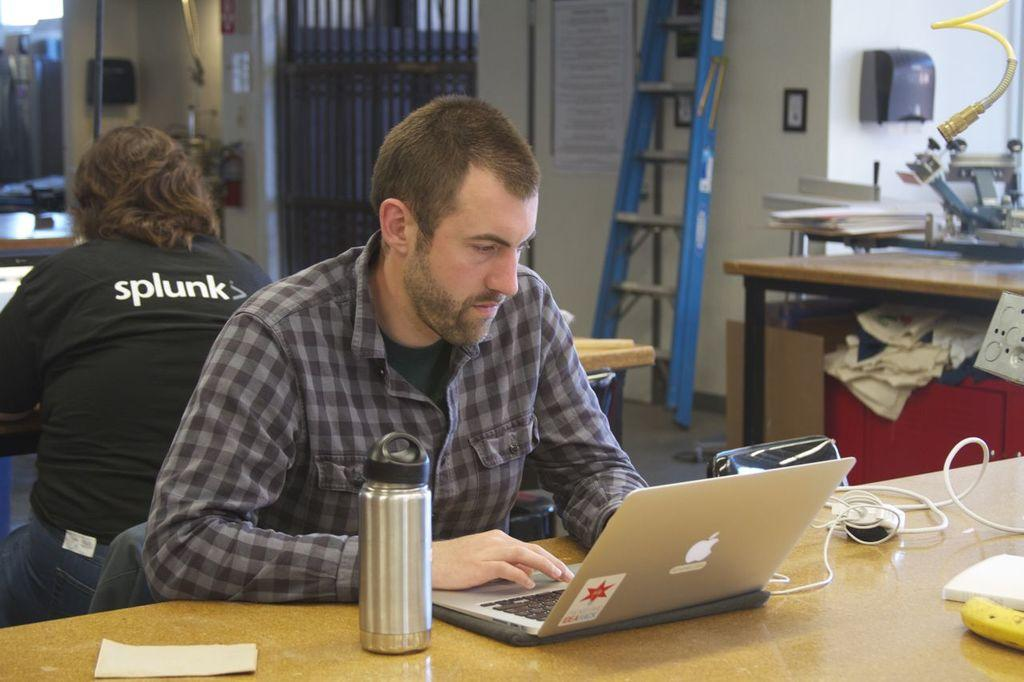What is the man in the image doing at the table? The man is working on his laptop. Can you describe the setting in which the man is working? The man is sitting at a table. Are there any other people present in the image? Yes, there is another man sitting behind him in the image. What type of territory can be seen in the image? There is no territory visible in the image; it features a man working on his laptop at a table. Can you describe the street where the man is working in the image? There is no street visible in the image; it features a man working on his laptop at a table. 